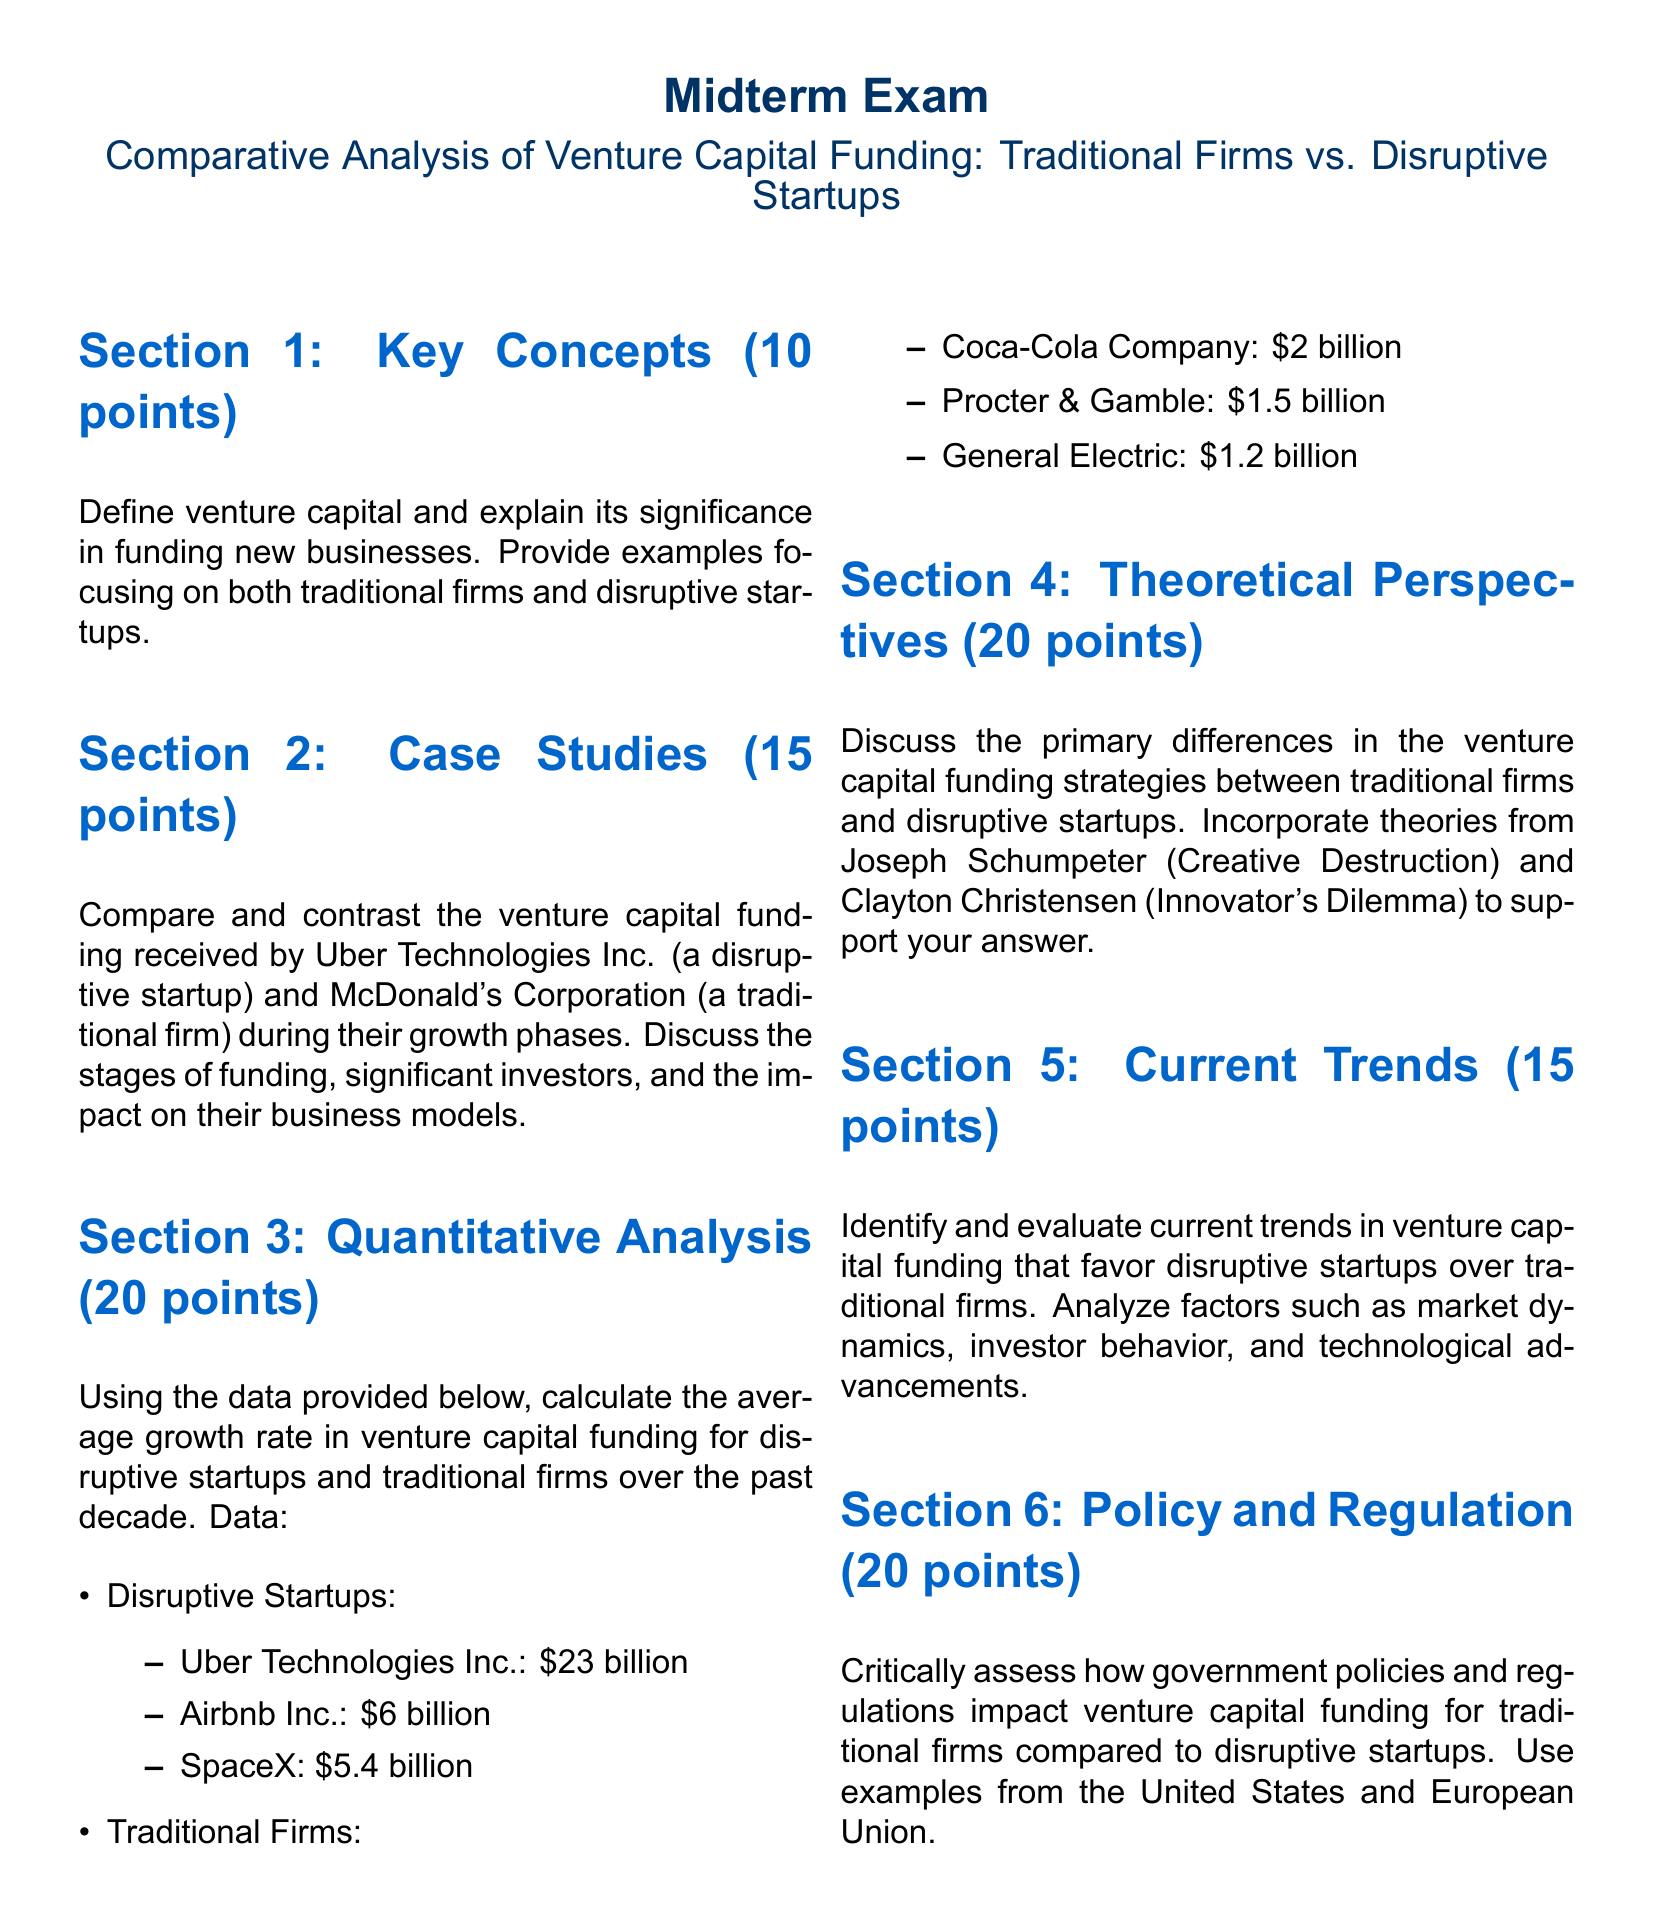What is the total venture capital funding for Uber Technologies Inc.? The funding amount for Uber Technologies Inc. is specified in Section 3, which states it received 23 billion dollars.
Answer: 23 billion How many points is Section 1 worth? The point value for Section 1 is clearly indicated at the beginning of that section, which is 10 points.
Answer: 10 Which firm is mentioned as a traditional firm in Section 2? McDonald's Corporation is explicitly stated as a traditional firm in Section 2 of the document.
Answer: McDonald's Corporation What theoretical perspective is associated with the concept of creative destruction? Joseph Schumpeter is identified in Section 4 as the theorist related to the concept of creative destruction.
Answer: Joseph Schumpeter What is the average growth rate calculation based on? The average growth rate calculation is based on the venture capital funding data for disruptive startups and traditional firms provided in the document.
Answer: Venture capital funding data How many points is the Current Trends section worth? The points allocated for the Current Trends section is specified at the start of that section as 15 points.
Answer: 15 Which disruptive startup received 6 billion dollars in funding? Airbnb Inc. is mentioned in the document as the disruptive startup that received 6 billion dollars in funding.
Answer: Airbnb Inc What are the two main theories referenced in Section 4? The two theories referenced in Section 4 are from Joseph Schumpeter and Clayton Christensen, specifically regarding creative destruction and innovator's dilemma.
Answer: Creative destruction and innovator's dilemma What section compares the funding received by Uber and McDonald's? The section that compares funding received by Uber Technologies Inc. and McDonald's Corporation is Section 2.
Answer: Section 2 